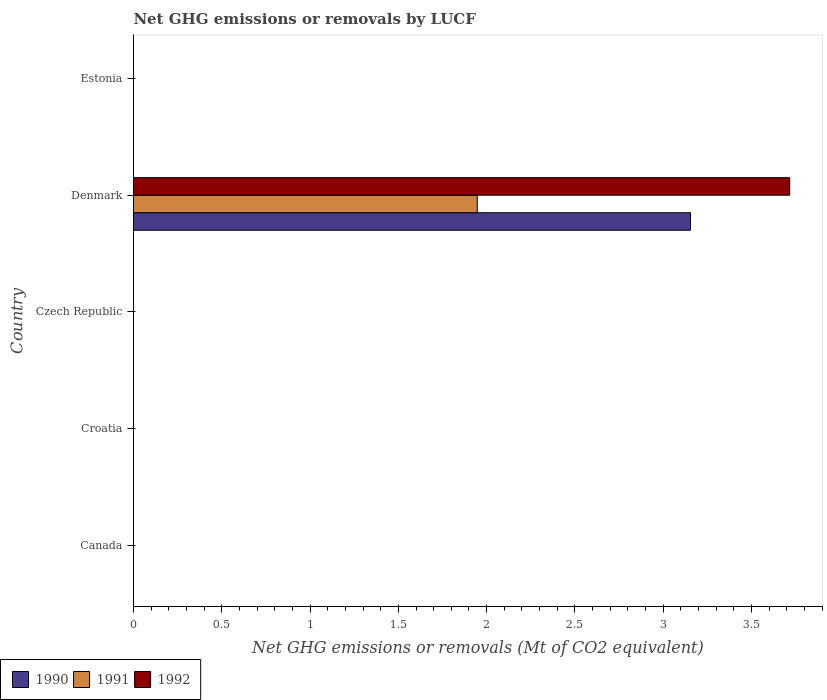Are the number of bars on each tick of the Y-axis equal?
Offer a terse response. No. How many bars are there on the 1st tick from the bottom?
Your response must be concise. 0. What is the label of the 3rd group of bars from the top?
Your answer should be very brief. Czech Republic. Across all countries, what is the maximum net GHG emissions or removals by LUCF in 1990?
Your response must be concise. 3.15. What is the total net GHG emissions or removals by LUCF in 1991 in the graph?
Ensure brevity in your answer.  1.95. What is the difference between the net GHG emissions or removals by LUCF in 1991 in Croatia and the net GHG emissions or removals by LUCF in 1990 in Canada?
Make the answer very short. 0. What is the average net GHG emissions or removals by LUCF in 1990 per country?
Your answer should be very brief. 0.63. What is the difference between the net GHG emissions or removals by LUCF in 1992 and net GHG emissions or removals by LUCF in 1990 in Denmark?
Ensure brevity in your answer.  0.56. In how many countries, is the net GHG emissions or removals by LUCF in 1992 greater than 2.3 Mt?
Give a very brief answer. 1. What is the difference between the highest and the lowest net GHG emissions or removals by LUCF in 1991?
Offer a terse response. 1.95. Are all the bars in the graph horizontal?
Your answer should be very brief. Yes. What is the difference between two consecutive major ticks on the X-axis?
Offer a very short reply. 0.5. Does the graph contain any zero values?
Offer a terse response. Yes. Does the graph contain grids?
Make the answer very short. No. Where does the legend appear in the graph?
Your answer should be very brief. Bottom left. How many legend labels are there?
Give a very brief answer. 3. What is the title of the graph?
Keep it short and to the point. Net GHG emissions or removals by LUCF. What is the label or title of the X-axis?
Your answer should be compact. Net GHG emissions or removals (Mt of CO2 equivalent). What is the Net GHG emissions or removals (Mt of CO2 equivalent) in 1990 in Canada?
Provide a short and direct response. 0. What is the Net GHG emissions or removals (Mt of CO2 equivalent) of 1991 in Canada?
Offer a very short reply. 0. What is the Net GHG emissions or removals (Mt of CO2 equivalent) of 1990 in Croatia?
Provide a short and direct response. 0. What is the Net GHG emissions or removals (Mt of CO2 equivalent) of 1990 in Czech Republic?
Your answer should be very brief. 0. What is the Net GHG emissions or removals (Mt of CO2 equivalent) in 1991 in Czech Republic?
Give a very brief answer. 0. What is the Net GHG emissions or removals (Mt of CO2 equivalent) of 1992 in Czech Republic?
Provide a short and direct response. 0. What is the Net GHG emissions or removals (Mt of CO2 equivalent) in 1990 in Denmark?
Your answer should be very brief. 3.15. What is the Net GHG emissions or removals (Mt of CO2 equivalent) of 1991 in Denmark?
Provide a succinct answer. 1.95. What is the Net GHG emissions or removals (Mt of CO2 equivalent) in 1992 in Denmark?
Ensure brevity in your answer.  3.72. What is the Net GHG emissions or removals (Mt of CO2 equivalent) in 1990 in Estonia?
Keep it short and to the point. 0. Across all countries, what is the maximum Net GHG emissions or removals (Mt of CO2 equivalent) of 1990?
Offer a terse response. 3.15. Across all countries, what is the maximum Net GHG emissions or removals (Mt of CO2 equivalent) in 1991?
Offer a terse response. 1.95. Across all countries, what is the maximum Net GHG emissions or removals (Mt of CO2 equivalent) in 1992?
Make the answer very short. 3.72. Across all countries, what is the minimum Net GHG emissions or removals (Mt of CO2 equivalent) in 1991?
Keep it short and to the point. 0. Across all countries, what is the minimum Net GHG emissions or removals (Mt of CO2 equivalent) in 1992?
Keep it short and to the point. 0. What is the total Net GHG emissions or removals (Mt of CO2 equivalent) of 1990 in the graph?
Provide a succinct answer. 3.15. What is the total Net GHG emissions or removals (Mt of CO2 equivalent) in 1991 in the graph?
Provide a short and direct response. 1.95. What is the total Net GHG emissions or removals (Mt of CO2 equivalent) of 1992 in the graph?
Offer a very short reply. 3.72. What is the average Net GHG emissions or removals (Mt of CO2 equivalent) of 1990 per country?
Offer a very short reply. 0.63. What is the average Net GHG emissions or removals (Mt of CO2 equivalent) of 1991 per country?
Offer a terse response. 0.39. What is the average Net GHG emissions or removals (Mt of CO2 equivalent) in 1992 per country?
Your response must be concise. 0.74. What is the difference between the Net GHG emissions or removals (Mt of CO2 equivalent) in 1990 and Net GHG emissions or removals (Mt of CO2 equivalent) in 1991 in Denmark?
Provide a succinct answer. 1.21. What is the difference between the Net GHG emissions or removals (Mt of CO2 equivalent) of 1990 and Net GHG emissions or removals (Mt of CO2 equivalent) of 1992 in Denmark?
Offer a very short reply. -0.56. What is the difference between the Net GHG emissions or removals (Mt of CO2 equivalent) in 1991 and Net GHG emissions or removals (Mt of CO2 equivalent) in 1992 in Denmark?
Offer a very short reply. -1.77. What is the difference between the highest and the lowest Net GHG emissions or removals (Mt of CO2 equivalent) in 1990?
Make the answer very short. 3.15. What is the difference between the highest and the lowest Net GHG emissions or removals (Mt of CO2 equivalent) of 1991?
Provide a succinct answer. 1.95. What is the difference between the highest and the lowest Net GHG emissions or removals (Mt of CO2 equivalent) of 1992?
Keep it short and to the point. 3.72. 